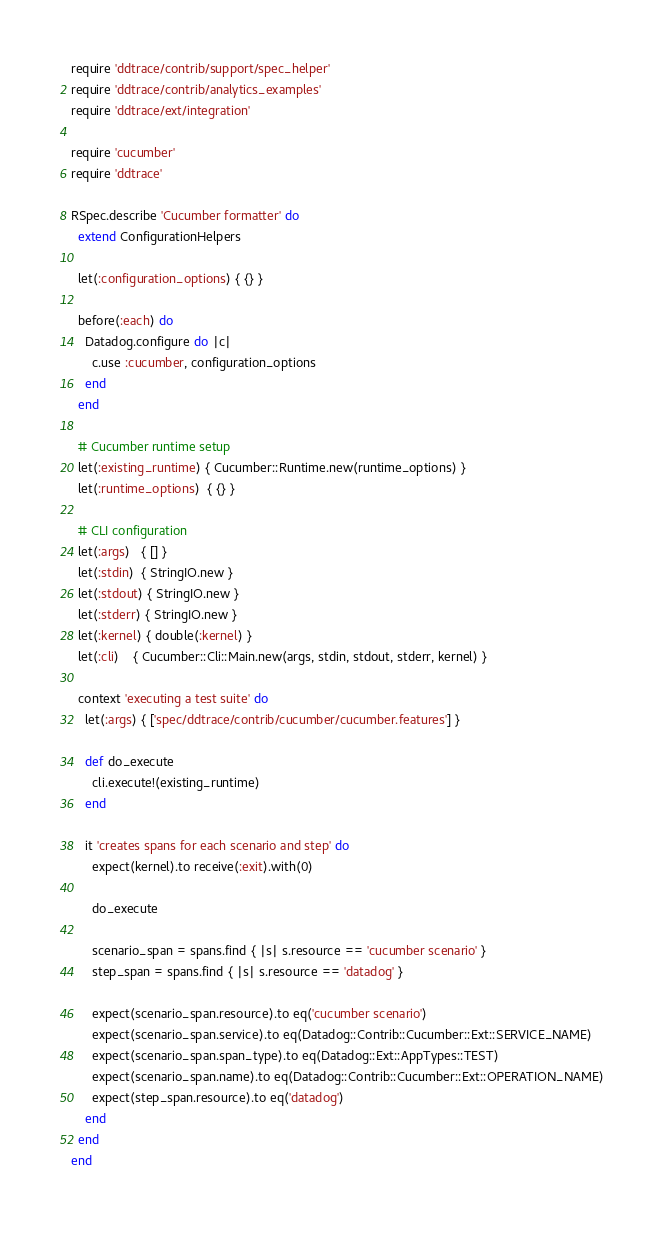<code> <loc_0><loc_0><loc_500><loc_500><_Ruby_>require 'ddtrace/contrib/support/spec_helper'
require 'ddtrace/contrib/analytics_examples'
require 'ddtrace/ext/integration'

require 'cucumber'
require 'ddtrace'

RSpec.describe 'Cucumber formatter' do
  extend ConfigurationHelpers

  let(:configuration_options) { {} }

  before(:each) do
    Datadog.configure do |c|
      c.use :cucumber, configuration_options
    end
  end

  # Cucumber runtime setup
  let(:existing_runtime) { Cucumber::Runtime.new(runtime_options) }
  let(:runtime_options)  { {} }

  # CLI configuration
  let(:args)   { [] }
  let(:stdin)  { StringIO.new }
  let(:stdout) { StringIO.new }
  let(:stderr) { StringIO.new }
  let(:kernel) { double(:kernel) }
  let(:cli)    { Cucumber::Cli::Main.new(args, stdin, stdout, stderr, kernel) }

  context 'executing a test suite' do
    let(:args) { ['spec/ddtrace/contrib/cucumber/cucumber.features'] }

    def do_execute
      cli.execute!(existing_runtime)
    end

    it 'creates spans for each scenario and step' do
      expect(kernel).to receive(:exit).with(0)

      do_execute

      scenario_span = spans.find { |s| s.resource == 'cucumber scenario' }
      step_span = spans.find { |s| s.resource == 'datadog' }

      expect(scenario_span.resource).to eq('cucumber scenario')
      expect(scenario_span.service).to eq(Datadog::Contrib::Cucumber::Ext::SERVICE_NAME)
      expect(scenario_span.span_type).to eq(Datadog::Ext::AppTypes::TEST)
      expect(scenario_span.name).to eq(Datadog::Contrib::Cucumber::Ext::OPERATION_NAME)
      expect(step_span.resource).to eq('datadog')
    end
  end
end
</code> 